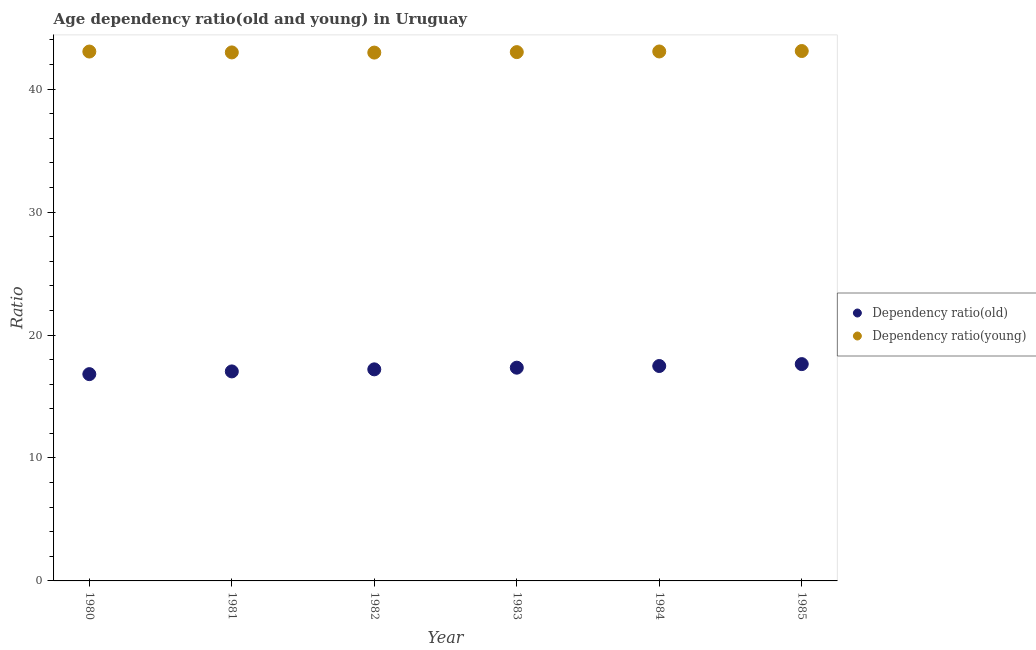How many different coloured dotlines are there?
Make the answer very short. 2. Is the number of dotlines equal to the number of legend labels?
Your answer should be compact. Yes. What is the age dependency ratio(old) in 1981?
Provide a succinct answer. 17.04. Across all years, what is the maximum age dependency ratio(young)?
Offer a terse response. 43.1. Across all years, what is the minimum age dependency ratio(young)?
Give a very brief answer. 42.97. What is the total age dependency ratio(old) in the graph?
Provide a short and direct response. 103.53. What is the difference between the age dependency ratio(young) in 1980 and that in 1985?
Make the answer very short. -0.04. What is the difference between the age dependency ratio(old) in 1983 and the age dependency ratio(young) in 1984?
Offer a very short reply. -25.72. What is the average age dependency ratio(old) per year?
Ensure brevity in your answer.  17.26. In the year 1981, what is the difference between the age dependency ratio(old) and age dependency ratio(young)?
Make the answer very short. -25.95. In how many years, is the age dependency ratio(young) greater than 14?
Provide a succinct answer. 6. What is the ratio of the age dependency ratio(old) in 1982 to that in 1985?
Ensure brevity in your answer.  0.98. Is the age dependency ratio(young) in 1980 less than that in 1981?
Keep it short and to the point. No. What is the difference between the highest and the second highest age dependency ratio(old)?
Ensure brevity in your answer.  0.15. What is the difference between the highest and the lowest age dependency ratio(young)?
Offer a terse response. 0.13. Does the age dependency ratio(old) monotonically increase over the years?
Provide a short and direct response. Yes. Is the age dependency ratio(young) strictly greater than the age dependency ratio(old) over the years?
Give a very brief answer. Yes. How many dotlines are there?
Provide a short and direct response. 2. What is the difference between two consecutive major ticks on the Y-axis?
Your answer should be compact. 10. Does the graph contain any zero values?
Provide a succinct answer. No. Does the graph contain grids?
Your answer should be compact. No. How many legend labels are there?
Make the answer very short. 2. How are the legend labels stacked?
Offer a terse response. Vertical. What is the title of the graph?
Ensure brevity in your answer.  Age dependency ratio(old and young) in Uruguay. What is the label or title of the X-axis?
Your response must be concise. Year. What is the label or title of the Y-axis?
Make the answer very short. Ratio. What is the Ratio in Dependency ratio(old) in 1980?
Your answer should be compact. 16.82. What is the Ratio in Dependency ratio(young) in 1980?
Provide a succinct answer. 43.06. What is the Ratio in Dependency ratio(old) in 1981?
Give a very brief answer. 17.04. What is the Ratio of Dependency ratio(young) in 1981?
Your response must be concise. 42.99. What is the Ratio of Dependency ratio(old) in 1982?
Offer a very short reply. 17.21. What is the Ratio in Dependency ratio(young) in 1982?
Your answer should be compact. 42.97. What is the Ratio of Dependency ratio(old) in 1983?
Provide a succinct answer. 17.34. What is the Ratio in Dependency ratio(young) in 1983?
Make the answer very short. 43.01. What is the Ratio of Dependency ratio(old) in 1984?
Provide a short and direct response. 17.48. What is the Ratio in Dependency ratio(young) in 1984?
Your response must be concise. 43.06. What is the Ratio in Dependency ratio(old) in 1985?
Provide a short and direct response. 17.64. What is the Ratio of Dependency ratio(young) in 1985?
Keep it short and to the point. 43.1. Across all years, what is the maximum Ratio in Dependency ratio(old)?
Your response must be concise. 17.64. Across all years, what is the maximum Ratio in Dependency ratio(young)?
Your answer should be compact. 43.1. Across all years, what is the minimum Ratio of Dependency ratio(old)?
Ensure brevity in your answer.  16.82. Across all years, what is the minimum Ratio of Dependency ratio(young)?
Provide a succinct answer. 42.97. What is the total Ratio in Dependency ratio(old) in the graph?
Your answer should be compact. 103.53. What is the total Ratio of Dependency ratio(young) in the graph?
Your answer should be compact. 258.2. What is the difference between the Ratio in Dependency ratio(old) in 1980 and that in 1981?
Make the answer very short. -0.22. What is the difference between the Ratio in Dependency ratio(young) in 1980 and that in 1981?
Ensure brevity in your answer.  0.07. What is the difference between the Ratio in Dependency ratio(old) in 1980 and that in 1982?
Make the answer very short. -0.39. What is the difference between the Ratio of Dependency ratio(young) in 1980 and that in 1982?
Your answer should be very brief. 0.09. What is the difference between the Ratio of Dependency ratio(old) in 1980 and that in 1983?
Provide a short and direct response. -0.52. What is the difference between the Ratio of Dependency ratio(young) in 1980 and that in 1983?
Provide a succinct answer. 0.05. What is the difference between the Ratio in Dependency ratio(old) in 1980 and that in 1984?
Give a very brief answer. -0.66. What is the difference between the Ratio of Dependency ratio(young) in 1980 and that in 1984?
Give a very brief answer. -0.01. What is the difference between the Ratio in Dependency ratio(old) in 1980 and that in 1985?
Provide a succinct answer. -0.82. What is the difference between the Ratio of Dependency ratio(young) in 1980 and that in 1985?
Provide a succinct answer. -0.04. What is the difference between the Ratio of Dependency ratio(old) in 1981 and that in 1982?
Provide a short and direct response. -0.17. What is the difference between the Ratio in Dependency ratio(young) in 1981 and that in 1982?
Offer a terse response. 0.01. What is the difference between the Ratio of Dependency ratio(old) in 1981 and that in 1983?
Your answer should be compact. -0.3. What is the difference between the Ratio in Dependency ratio(young) in 1981 and that in 1983?
Provide a short and direct response. -0.03. What is the difference between the Ratio of Dependency ratio(old) in 1981 and that in 1984?
Provide a succinct answer. -0.44. What is the difference between the Ratio in Dependency ratio(young) in 1981 and that in 1984?
Give a very brief answer. -0.08. What is the difference between the Ratio of Dependency ratio(old) in 1981 and that in 1985?
Offer a terse response. -0.59. What is the difference between the Ratio in Dependency ratio(young) in 1981 and that in 1985?
Your answer should be very brief. -0.11. What is the difference between the Ratio in Dependency ratio(old) in 1982 and that in 1983?
Offer a terse response. -0.14. What is the difference between the Ratio in Dependency ratio(young) in 1982 and that in 1983?
Give a very brief answer. -0.04. What is the difference between the Ratio of Dependency ratio(old) in 1982 and that in 1984?
Keep it short and to the point. -0.27. What is the difference between the Ratio of Dependency ratio(young) in 1982 and that in 1984?
Offer a very short reply. -0.09. What is the difference between the Ratio of Dependency ratio(old) in 1982 and that in 1985?
Keep it short and to the point. -0.43. What is the difference between the Ratio in Dependency ratio(young) in 1982 and that in 1985?
Your answer should be compact. -0.13. What is the difference between the Ratio of Dependency ratio(old) in 1983 and that in 1984?
Give a very brief answer. -0.14. What is the difference between the Ratio in Dependency ratio(young) in 1983 and that in 1984?
Ensure brevity in your answer.  -0.05. What is the difference between the Ratio in Dependency ratio(old) in 1983 and that in 1985?
Offer a terse response. -0.29. What is the difference between the Ratio in Dependency ratio(young) in 1983 and that in 1985?
Offer a very short reply. -0.09. What is the difference between the Ratio in Dependency ratio(old) in 1984 and that in 1985?
Your response must be concise. -0.15. What is the difference between the Ratio in Dependency ratio(young) in 1984 and that in 1985?
Provide a succinct answer. -0.04. What is the difference between the Ratio in Dependency ratio(old) in 1980 and the Ratio in Dependency ratio(young) in 1981?
Keep it short and to the point. -26.17. What is the difference between the Ratio in Dependency ratio(old) in 1980 and the Ratio in Dependency ratio(young) in 1982?
Offer a very short reply. -26.15. What is the difference between the Ratio in Dependency ratio(old) in 1980 and the Ratio in Dependency ratio(young) in 1983?
Offer a terse response. -26.19. What is the difference between the Ratio of Dependency ratio(old) in 1980 and the Ratio of Dependency ratio(young) in 1984?
Your response must be concise. -26.24. What is the difference between the Ratio of Dependency ratio(old) in 1980 and the Ratio of Dependency ratio(young) in 1985?
Make the answer very short. -26.28. What is the difference between the Ratio in Dependency ratio(old) in 1981 and the Ratio in Dependency ratio(young) in 1982?
Provide a succinct answer. -25.93. What is the difference between the Ratio in Dependency ratio(old) in 1981 and the Ratio in Dependency ratio(young) in 1983?
Ensure brevity in your answer.  -25.97. What is the difference between the Ratio in Dependency ratio(old) in 1981 and the Ratio in Dependency ratio(young) in 1984?
Your answer should be very brief. -26.02. What is the difference between the Ratio in Dependency ratio(old) in 1981 and the Ratio in Dependency ratio(young) in 1985?
Offer a terse response. -26.06. What is the difference between the Ratio in Dependency ratio(old) in 1982 and the Ratio in Dependency ratio(young) in 1983?
Make the answer very short. -25.8. What is the difference between the Ratio of Dependency ratio(old) in 1982 and the Ratio of Dependency ratio(young) in 1984?
Offer a very short reply. -25.86. What is the difference between the Ratio of Dependency ratio(old) in 1982 and the Ratio of Dependency ratio(young) in 1985?
Provide a short and direct response. -25.89. What is the difference between the Ratio in Dependency ratio(old) in 1983 and the Ratio in Dependency ratio(young) in 1984?
Provide a short and direct response. -25.72. What is the difference between the Ratio of Dependency ratio(old) in 1983 and the Ratio of Dependency ratio(young) in 1985?
Provide a short and direct response. -25.76. What is the difference between the Ratio in Dependency ratio(old) in 1984 and the Ratio in Dependency ratio(young) in 1985?
Make the answer very short. -25.62. What is the average Ratio in Dependency ratio(old) per year?
Your answer should be compact. 17.26. What is the average Ratio in Dependency ratio(young) per year?
Keep it short and to the point. 43.03. In the year 1980, what is the difference between the Ratio in Dependency ratio(old) and Ratio in Dependency ratio(young)?
Offer a terse response. -26.24. In the year 1981, what is the difference between the Ratio in Dependency ratio(old) and Ratio in Dependency ratio(young)?
Offer a very short reply. -25.95. In the year 1982, what is the difference between the Ratio of Dependency ratio(old) and Ratio of Dependency ratio(young)?
Keep it short and to the point. -25.77. In the year 1983, what is the difference between the Ratio in Dependency ratio(old) and Ratio in Dependency ratio(young)?
Provide a succinct answer. -25.67. In the year 1984, what is the difference between the Ratio in Dependency ratio(old) and Ratio in Dependency ratio(young)?
Provide a succinct answer. -25.58. In the year 1985, what is the difference between the Ratio in Dependency ratio(old) and Ratio in Dependency ratio(young)?
Your answer should be compact. -25.47. What is the ratio of the Ratio of Dependency ratio(old) in 1980 to that in 1982?
Make the answer very short. 0.98. What is the ratio of the Ratio of Dependency ratio(young) in 1980 to that in 1982?
Ensure brevity in your answer.  1. What is the ratio of the Ratio in Dependency ratio(old) in 1980 to that in 1983?
Ensure brevity in your answer.  0.97. What is the ratio of the Ratio in Dependency ratio(old) in 1980 to that in 1984?
Your answer should be very brief. 0.96. What is the ratio of the Ratio in Dependency ratio(young) in 1980 to that in 1984?
Make the answer very short. 1. What is the ratio of the Ratio in Dependency ratio(old) in 1980 to that in 1985?
Provide a succinct answer. 0.95. What is the ratio of the Ratio of Dependency ratio(young) in 1980 to that in 1985?
Keep it short and to the point. 1. What is the ratio of the Ratio of Dependency ratio(old) in 1981 to that in 1982?
Keep it short and to the point. 0.99. What is the ratio of the Ratio in Dependency ratio(old) in 1981 to that in 1983?
Provide a short and direct response. 0.98. What is the ratio of the Ratio of Dependency ratio(young) in 1981 to that in 1983?
Your answer should be compact. 1. What is the ratio of the Ratio of Dependency ratio(old) in 1981 to that in 1984?
Provide a short and direct response. 0.97. What is the ratio of the Ratio in Dependency ratio(old) in 1981 to that in 1985?
Provide a succinct answer. 0.97. What is the ratio of the Ratio in Dependency ratio(young) in 1982 to that in 1983?
Your answer should be very brief. 1. What is the ratio of the Ratio of Dependency ratio(old) in 1982 to that in 1984?
Make the answer very short. 0.98. What is the ratio of the Ratio of Dependency ratio(old) in 1982 to that in 1985?
Make the answer very short. 0.98. What is the ratio of the Ratio in Dependency ratio(young) in 1982 to that in 1985?
Make the answer very short. 1. What is the ratio of the Ratio in Dependency ratio(old) in 1983 to that in 1984?
Provide a succinct answer. 0.99. What is the ratio of the Ratio of Dependency ratio(young) in 1983 to that in 1984?
Your answer should be compact. 1. What is the ratio of the Ratio of Dependency ratio(old) in 1983 to that in 1985?
Offer a very short reply. 0.98. What is the ratio of the Ratio in Dependency ratio(young) in 1983 to that in 1985?
Provide a succinct answer. 1. What is the ratio of the Ratio of Dependency ratio(young) in 1984 to that in 1985?
Your answer should be compact. 1. What is the difference between the highest and the second highest Ratio in Dependency ratio(old)?
Ensure brevity in your answer.  0.15. What is the difference between the highest and the second highest Ratio in Dependency ratio(young)?
Your answer should be compact. 0.04. What is the difference between the highest and the lowest Ratio of Dependency ratio(old)?
Your response must be concise. 0.82. What is the difference between the highest and the lowest Ratio of Dependency ratio(young)?
Ensure brevity in your answer.  0.13. 